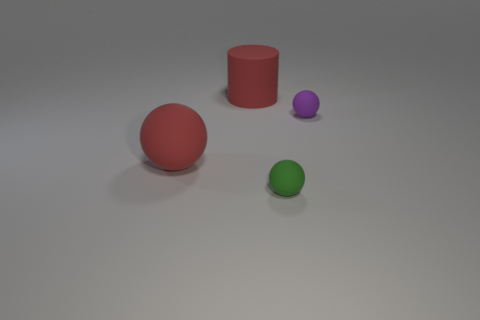What number of green rubber things have the same size as the purple rubber ball?
Your answer should be compact. 1. What number of green objects are either tiny spheres or large cylinders?
Give a very brief answer. 1. How many things are either small green rubber balls or big things in front of the red matte cylinder?
Provide a short and direct response. 2. There is a purple sphere that is behind the green rubber object; what is it made of?
Your answer should be very brief. Rubber. What is the shape of the red thing that is the same size as the red sphere?
Offer a very short reply. Cylinder. Are there any other large objects that have the same shape as the green object?
Keep it short and to the point. Yes. Is the material of the purple thing the same as the ball left of the small green matte object?
Ensure brevity in your answer.  Yes. The big red cylinder behind the large ball on the left side of the small green rubber thing is made of what material?
Keep it short and to the point. Rubber. Are there more red spheres in front of the red matte ball than big red rubber balls?
Offer a very short reply. No. Are any big cubes visible?
Provide a short and direct response. No. 